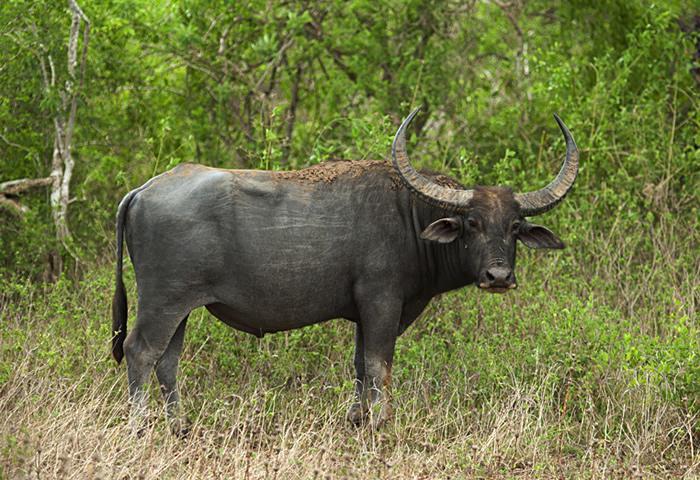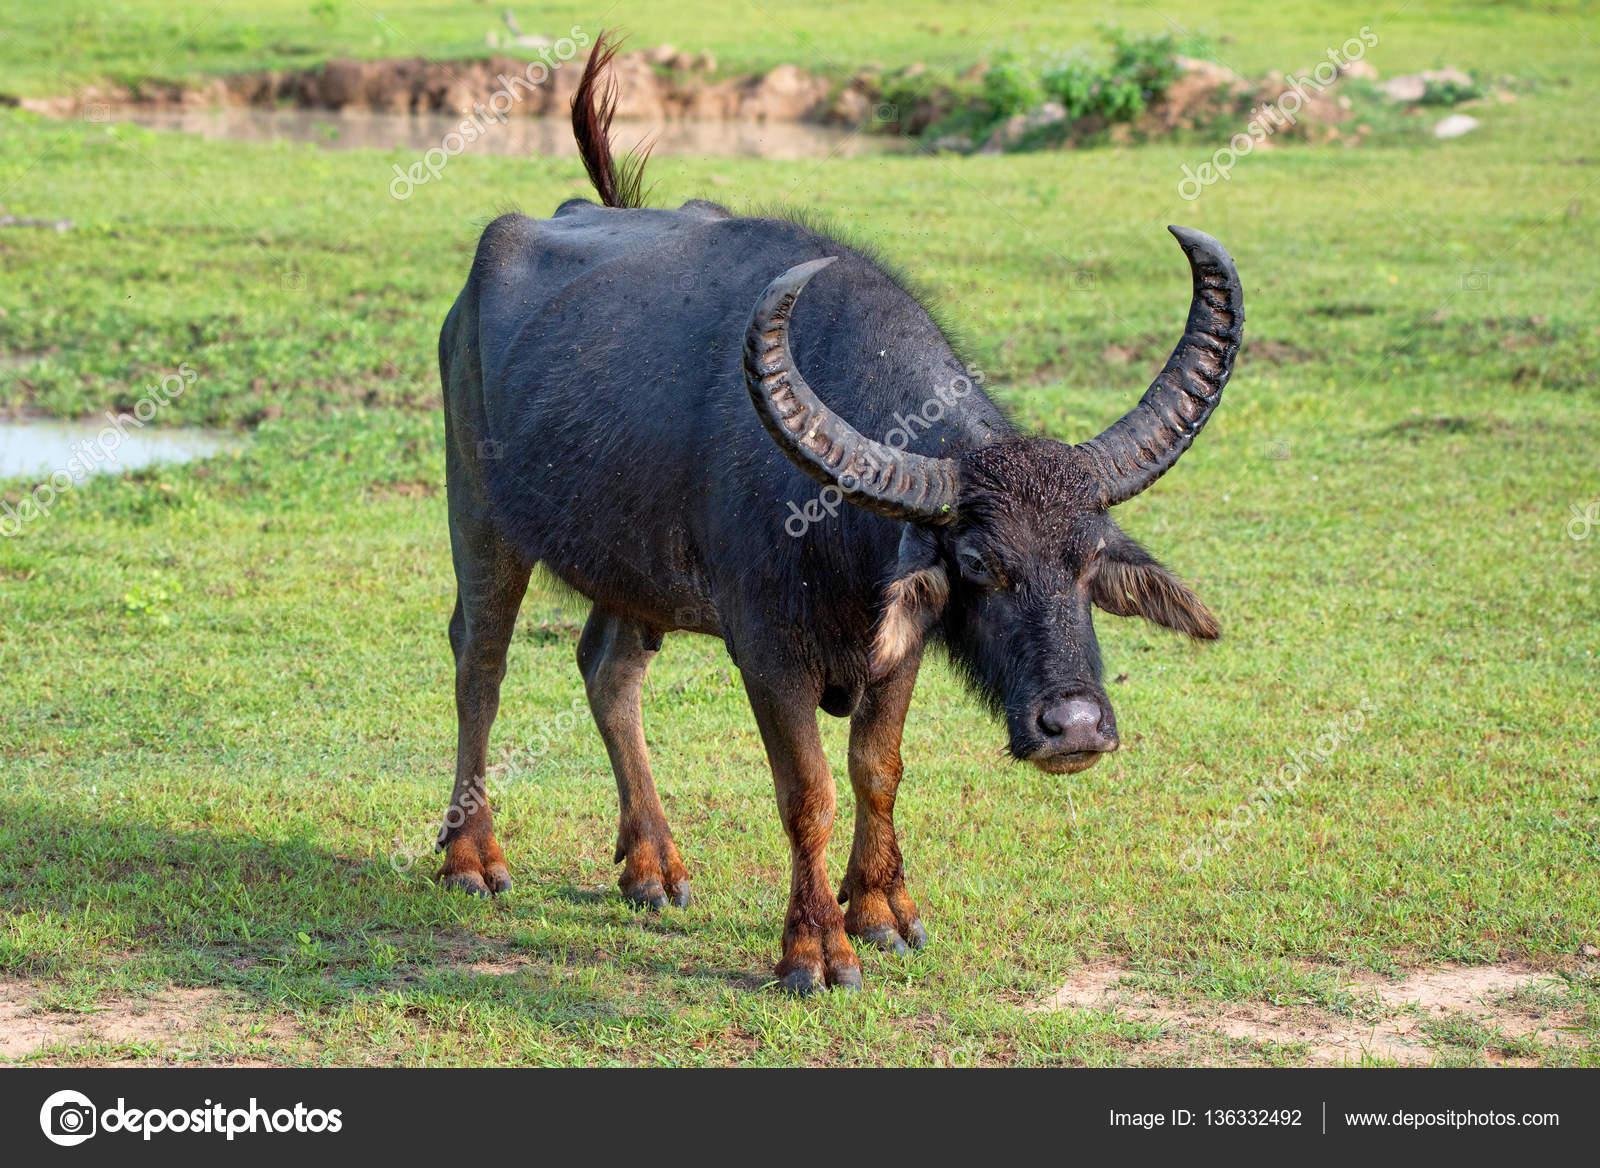The first image is the image on the left, the second image is the image on the right. Analyze the images presented: Is the assertion "There are exactly three animals in total." valid? Answer yes or no. No. The first image is the image on the left, the second image is the image on the right. For the images displayed, is the sentence "There are exactly three animals with horns that are visible." factually correct? Answer yes or no. No. 